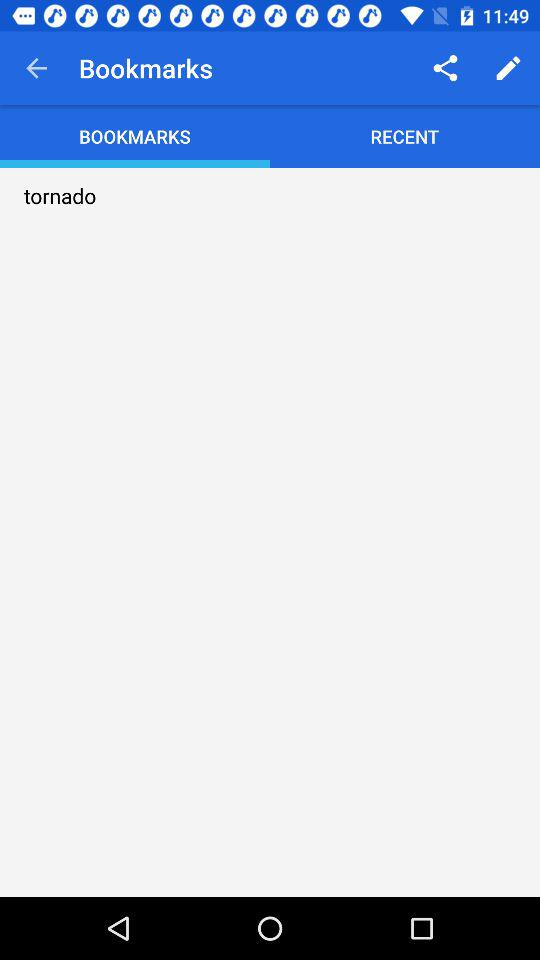What item is bookmarked? The bookmarked item is "tornado". 